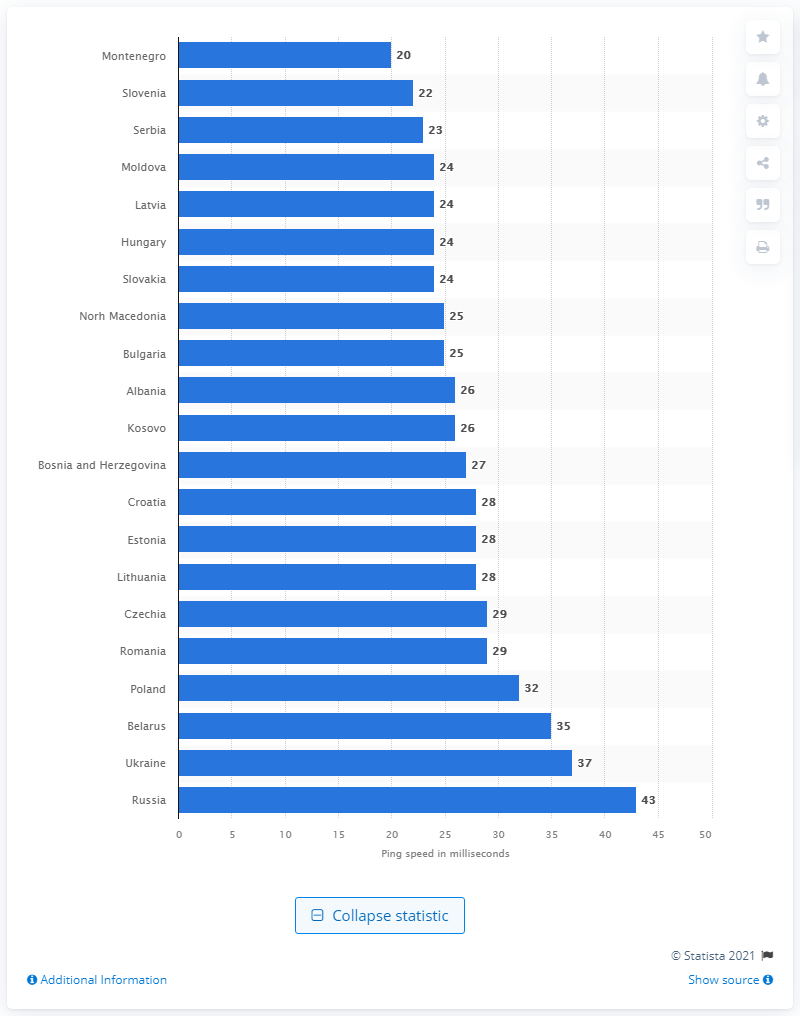Give some essential details in this illustration. According to the CEE region, Bulgaria provided the fastest mobile internet speed among other countries. 